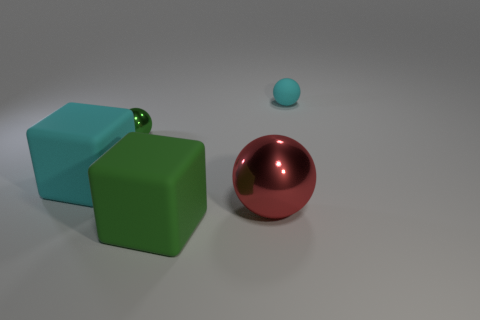Could you describe the textures of the different objects? Certainly! The larger teal cube and green sphere have a matte, solid finish with no noticeable texture, which makes them look smooth. In contrast, the larger red sphere and the small blue ball have a more shiny, reflective surface which suggests a smoother and possibly metallic texture. 